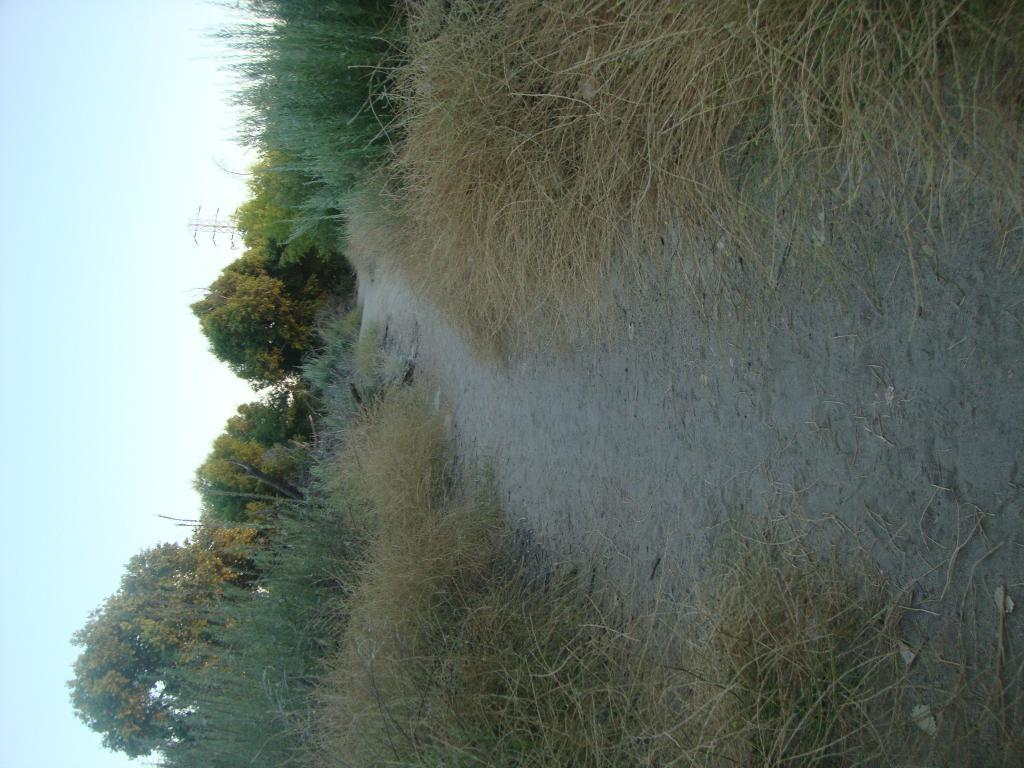What is the main feature of the image? There is a path in the image. What can be seen around the path? The path is surrounded by grass. What else is present in the middle of the image? There are trees in the middle of the image. What is visible on the left side of the image? The sky is visible on the left side of the image. How does the fly contribute to the digestion process in the image? There are no flies present in the image, so it is not possible to discuss their contribution to any digestion process. 